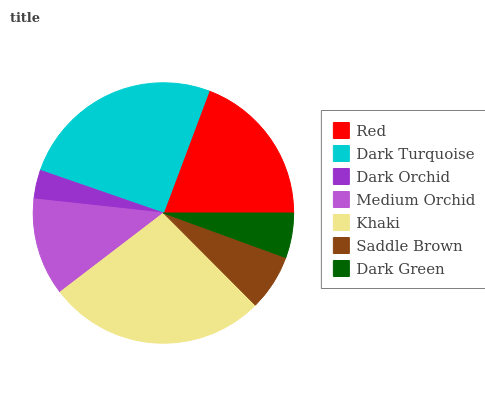Is Dark Orchid the minimum?
Answer yes or no. Yes. Is Khaki the maximum?
Answer yes or no. Yes. Is Dark Turquoise the minimum?
Answer yes or no. No. Is Dark Turquoise the maximum?
Answer yes or no. No. Is Dark Turquoise greater than Red?
Answer yes or no. Yes. Is Red less than Dark Turquoise?
Answer yes or no. Yes. Is Red greater than Dark Turquoise?
Answer yes or no. No. Is Dark Turquoise less than Red?
Answer yes or no. No. Is Medium Orchid the high median?
Answer yes or no. Yes. Is Medium Orchid the low median?
Answer yes or no. Yes. Is Dark Orchid the high median?
Answer yes or no. No. Is Dark Orchid the low median?
Answer yes or no. No. 